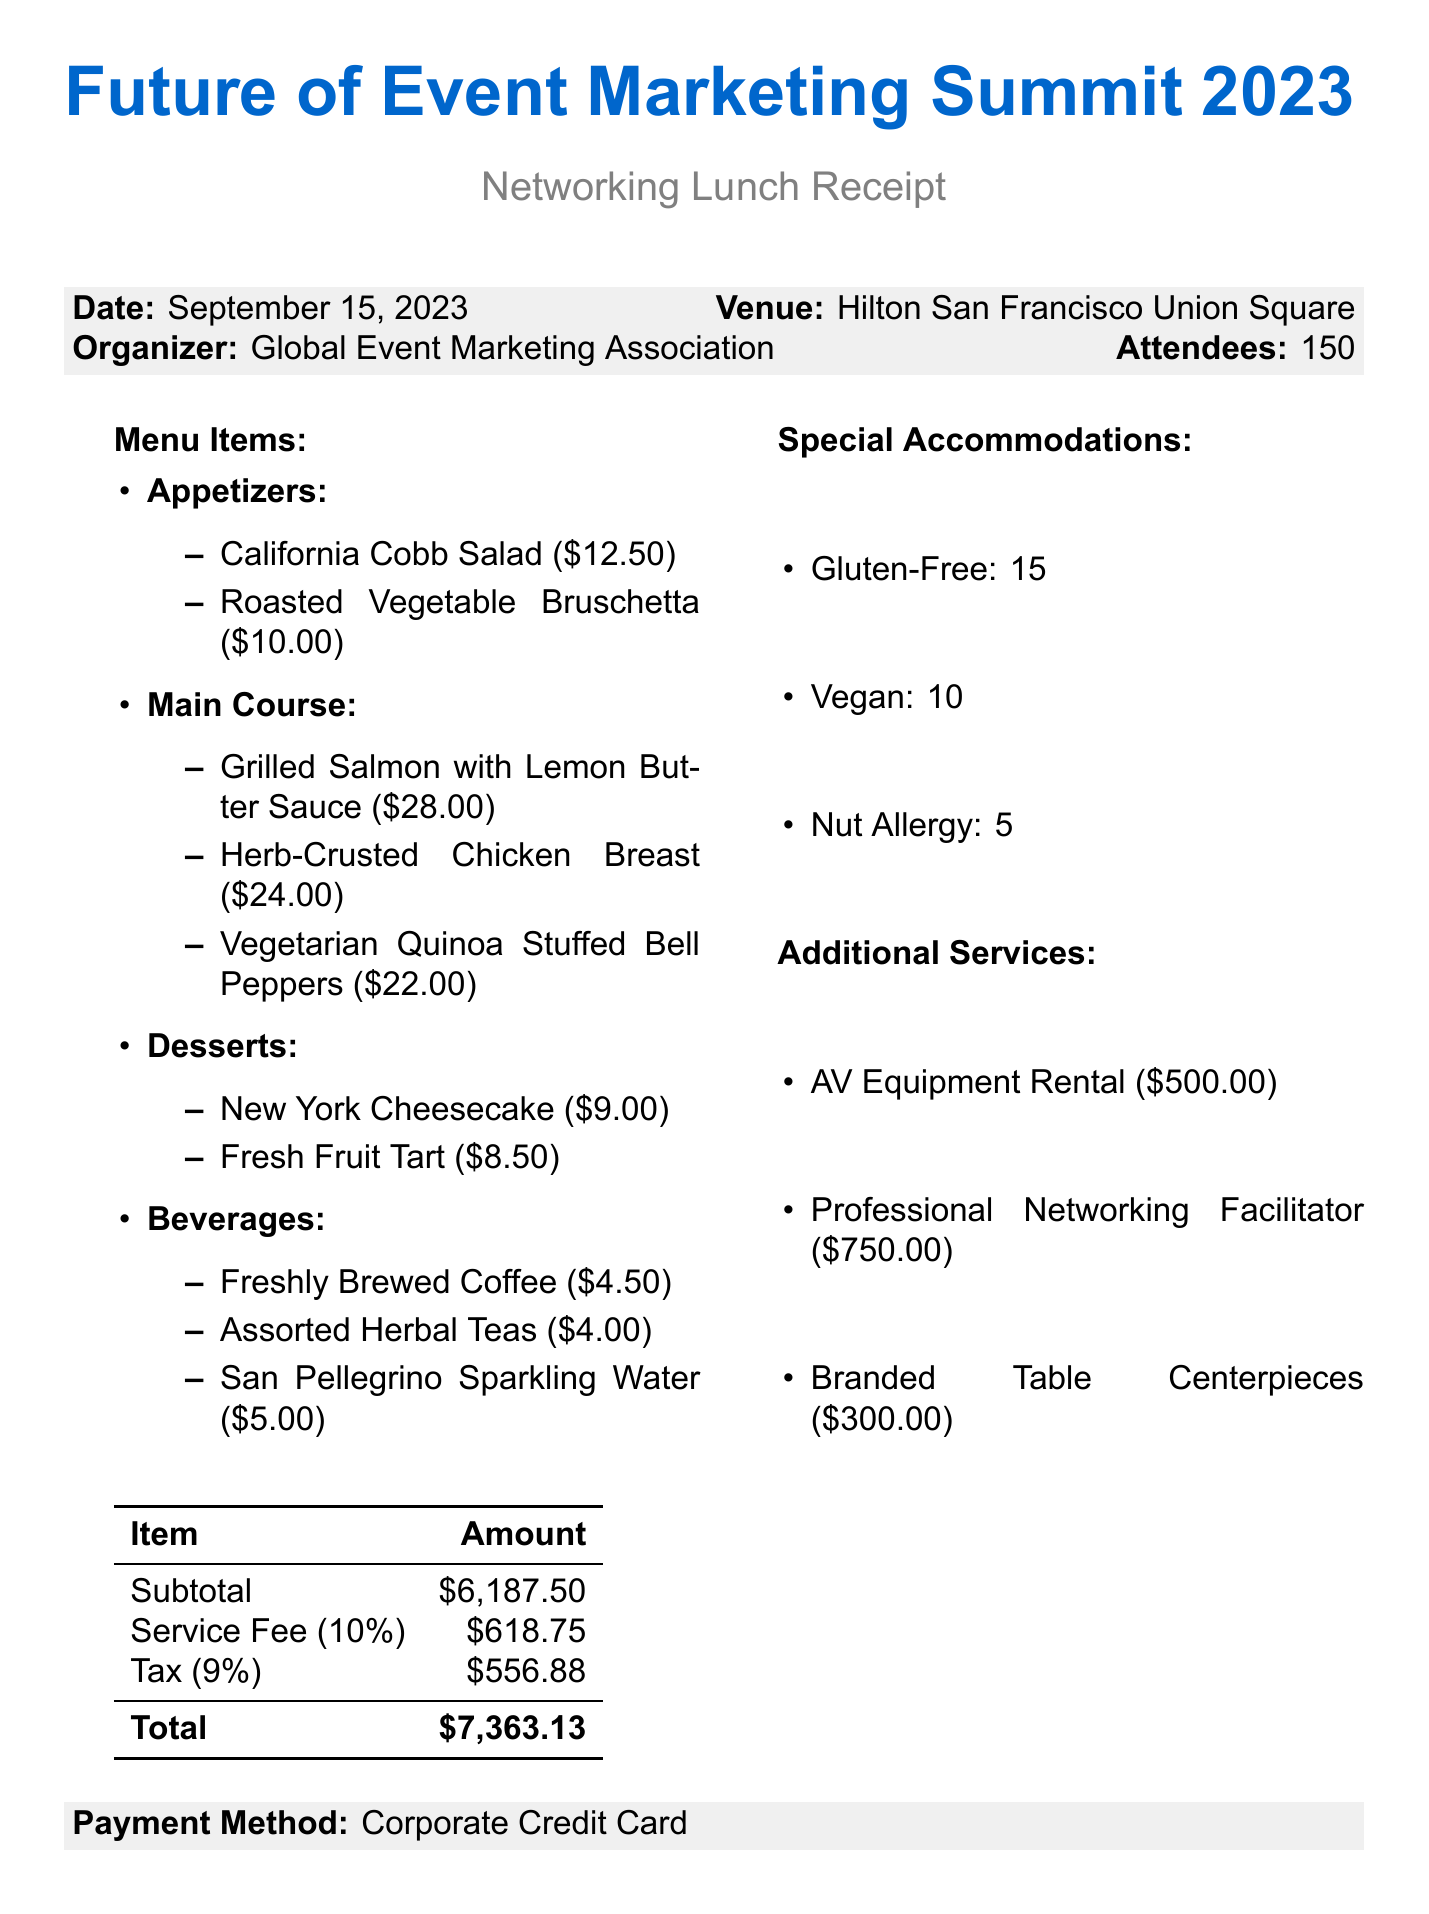What is the name of the event? The name of the event is clearly stated at the top of the document.
Answer: Future of Event Marketing Summit 2023 What is the date of the event? The date of the event is specified in the document header.
Answer: September 15, 2023 How many attendees were present? The number of attendees is listed in the event details.
Answer: 150 What is the total amount for the networking lunch? The total amount is calculated and presented at the end of the receipt.
Answer: $7363.13 How many Gluten-Free special accommodations were made? The number of Gluten-Free accommodations is mentioned in the special accommodations section.
Answer: 15 Which main course option is the most expensive? The prices of the main course items allow for a comparison to identify the most expensive.
Answer: Grilled Salmon with Lemon Butter Sauce What is the price of Freshly Brewed Coffee? The price for this beverage is specified in the beverages section of the menu.
Answer: $4.50 How much was charged for the Professional Networking Facilitator service? The charge for this additional service is outlined in the additional services section.
Answer: $750.00 What payment method was used for the lunch? The payment method is indicated in the payment information section of the document.
Answer: Corporate Credit Card 